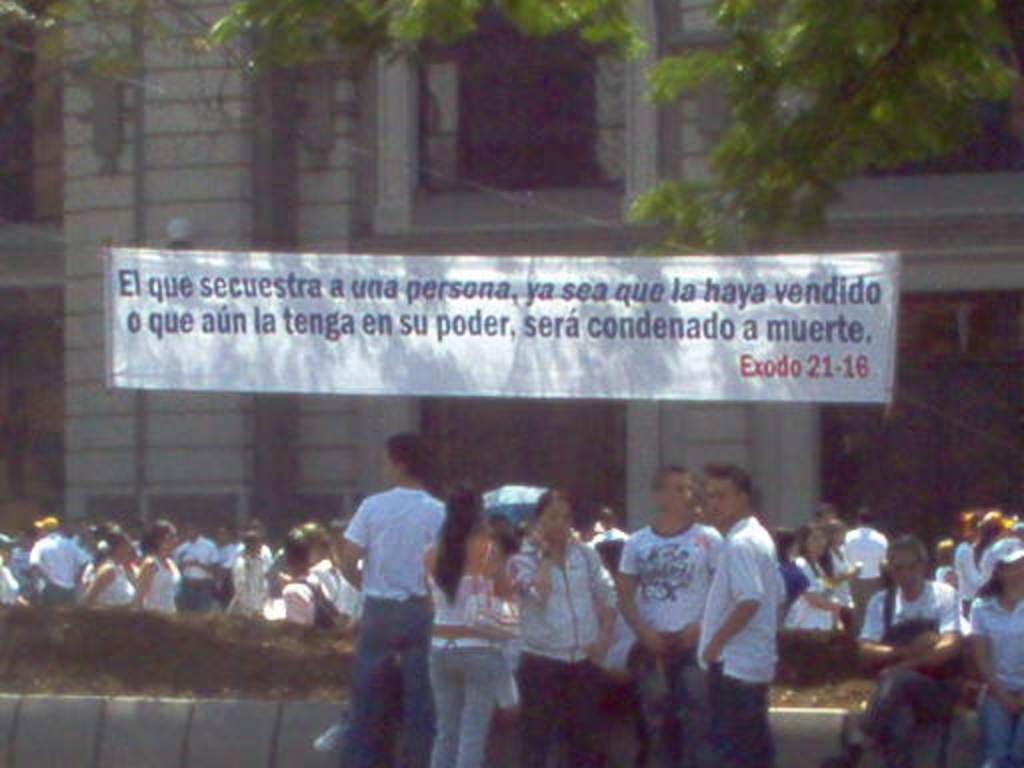What are the people in the image doing? Some people are sitting on a wall, and others are standing on the road in the image. What can be seen in the background of the image? There is an advertisement visible in the background of the image, which is hanged on a building, and there is also a tree visible. What reward does the father receive for starting the car in the image? There is no car, father, or reward present in the image. 